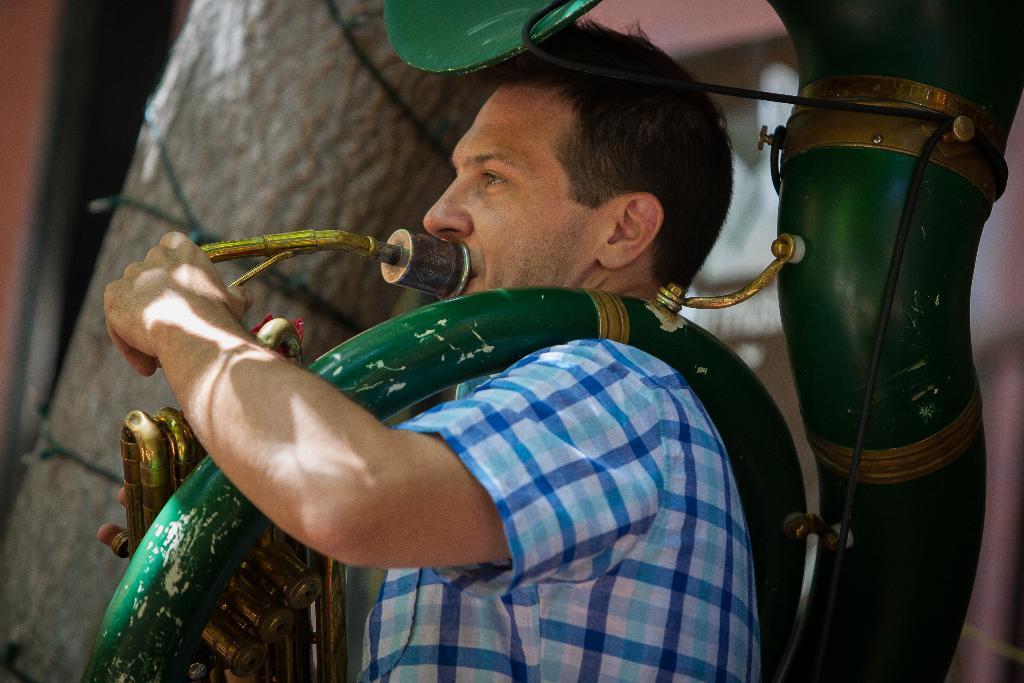Describe this image in one or two sentences. In the middle of the image we can see a man, he is playing a musical instrument. 